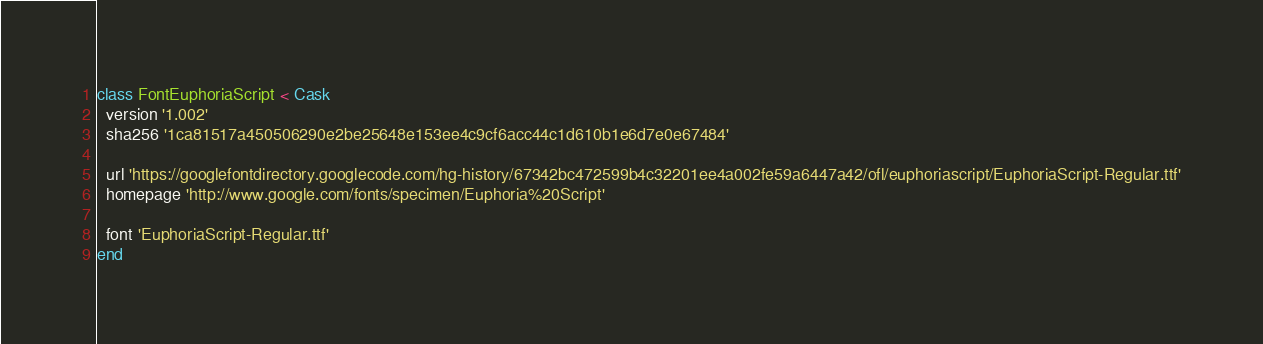Convert code to text. <code><loc_0><loc_0><loc_500><loc_500><_Ruby_>class FontEuphoriaScript < Cask
  version '1.002'
  sha256 '1ca81517a450506290e2be25648e153ee4c9cf6acc44c1d610b1e6d7e0e67484'

  url 'https://googlefontdirectory.googlecode.com/hg-history/67342bc472599b4c32201ee4a002fe59a6447a42/ofl/euphoriascript/EuphoriaScript-Regular.ttf'
  homepage 'http://www.google.com/fonts/specimen/Euphoria%20Script'

  font 'EuphoriaScript-Regular.ttf'
end
</code> 